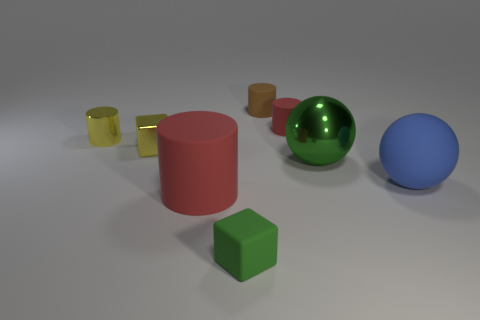How many red cylinders must be subtracted to get 1 red cylinders? 1 Subtract all gray spheres. Subtract all gray cylinders. How many spheres are left? 2 Add 1 tiny red rubber things. How many objects exist? 9 Subtract all cubes. How many objects are left? 6 Subtract 1 yellow cylinders. How many objects are left? 7 Subtract all cyan spheres. Subtract all tiny cylinders. How many objects are left? 5 Add 5 small green objects. How many small green objects are left? 6 Add 5 red rubber things. How many red rubber things exist? 7 